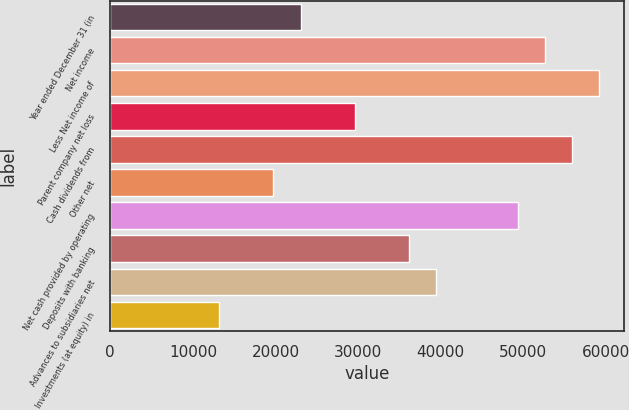Convert chart. <chart><loc_0><loc_0><loc_500><loc_500><bar_chart><fcel>Year ended December 31 (in<fcel>Net income<fcel>Less Net income of<fcel>Parent company net loss<fcel>Cash dividends from<fcel>Other net<fcel>Net cash provided by operating<fcel>Deposits with banking<fcel>Advances to subsidiaries net<fcel>Investments (at equity) in<nl><fcel>23026.9<fcel>52625.2<fcel>59202.6<fcel>29604.3<fcel>55913.9<fcel>19738.2<fcel>49336.5<fcel>36181.7<fcel>39470.4<fcel>13160.8<nl></chart> 